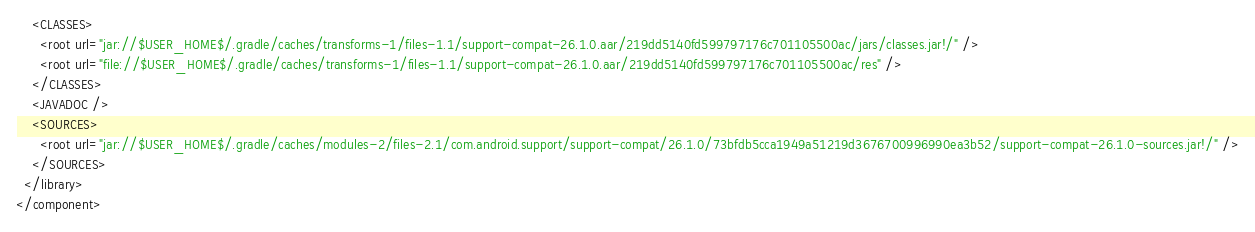Convert code to text. <code><loc_0><loc_0><loc_500><loc_500><_XML_>    <CLASSES>
      <root url="jar://$USER_HOME$/.gradle/caches/transforms-1/files-1.1/support-compat-26.1.0.aar/219dd5140fd599797176c701105500ac/jars/classes.jar!/" />
      <root url="file://$USER_HOME$/.gradle/caches/transforms-1/files-1.1/support-compat-26.1.0.aar/219dd5140fd599797176c701105500ac/res" />
    </CLASSES>
    <JAVADOC />
    <SOURCES>
      <root url="jar://$USER_HOME$/.gradle/caches/modules-2/files-2.1/com.android.support/support-compat/26.1.0/73bfdb5cca1949a51219d3676700996990ea3b52/support-compat-26.1.0-sources.jar!/" />
    </SOURCES>
  </library>
</component></code> 